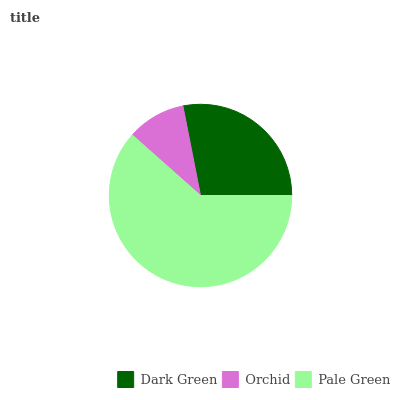Is Orchid the minimum?
Answer yes or no. Yes. Is Pale Green the maximum?
Answer yes or no. Yes. Is Pale Green the minimum?
Answer yes or no. No. Is Orchid the maximum?
Answer yes or no. No. Is Pale Green greater than Orchid?
Answer yes or no. Yes. Is Orchid less than Pale Green?
Answer yes or no. Yes. Is Orchid greater than Pale Green?
Answer yes or no. No. Is Pale Green less than Orchid?
Answer yes or no. No. Is Dark Green the high median?
Answer yes or no. Yes. Is Dark Green the low median?
Answer yes or no. Yes. Is Pale Green the high median?
Answer yes or no. No. Is Pale Green the low median?
Answer yes or no. No. 